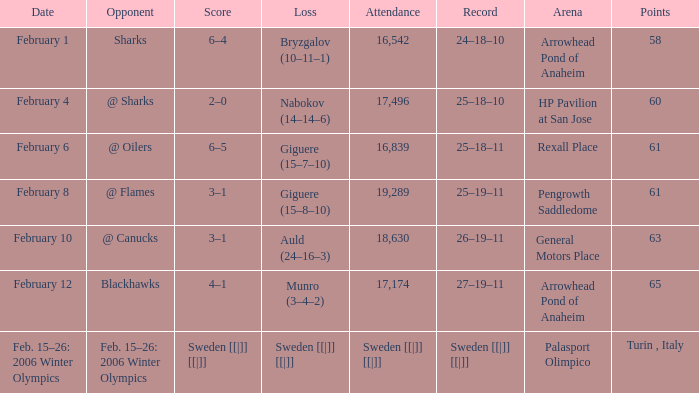What were the points on February 10? 63.0. 